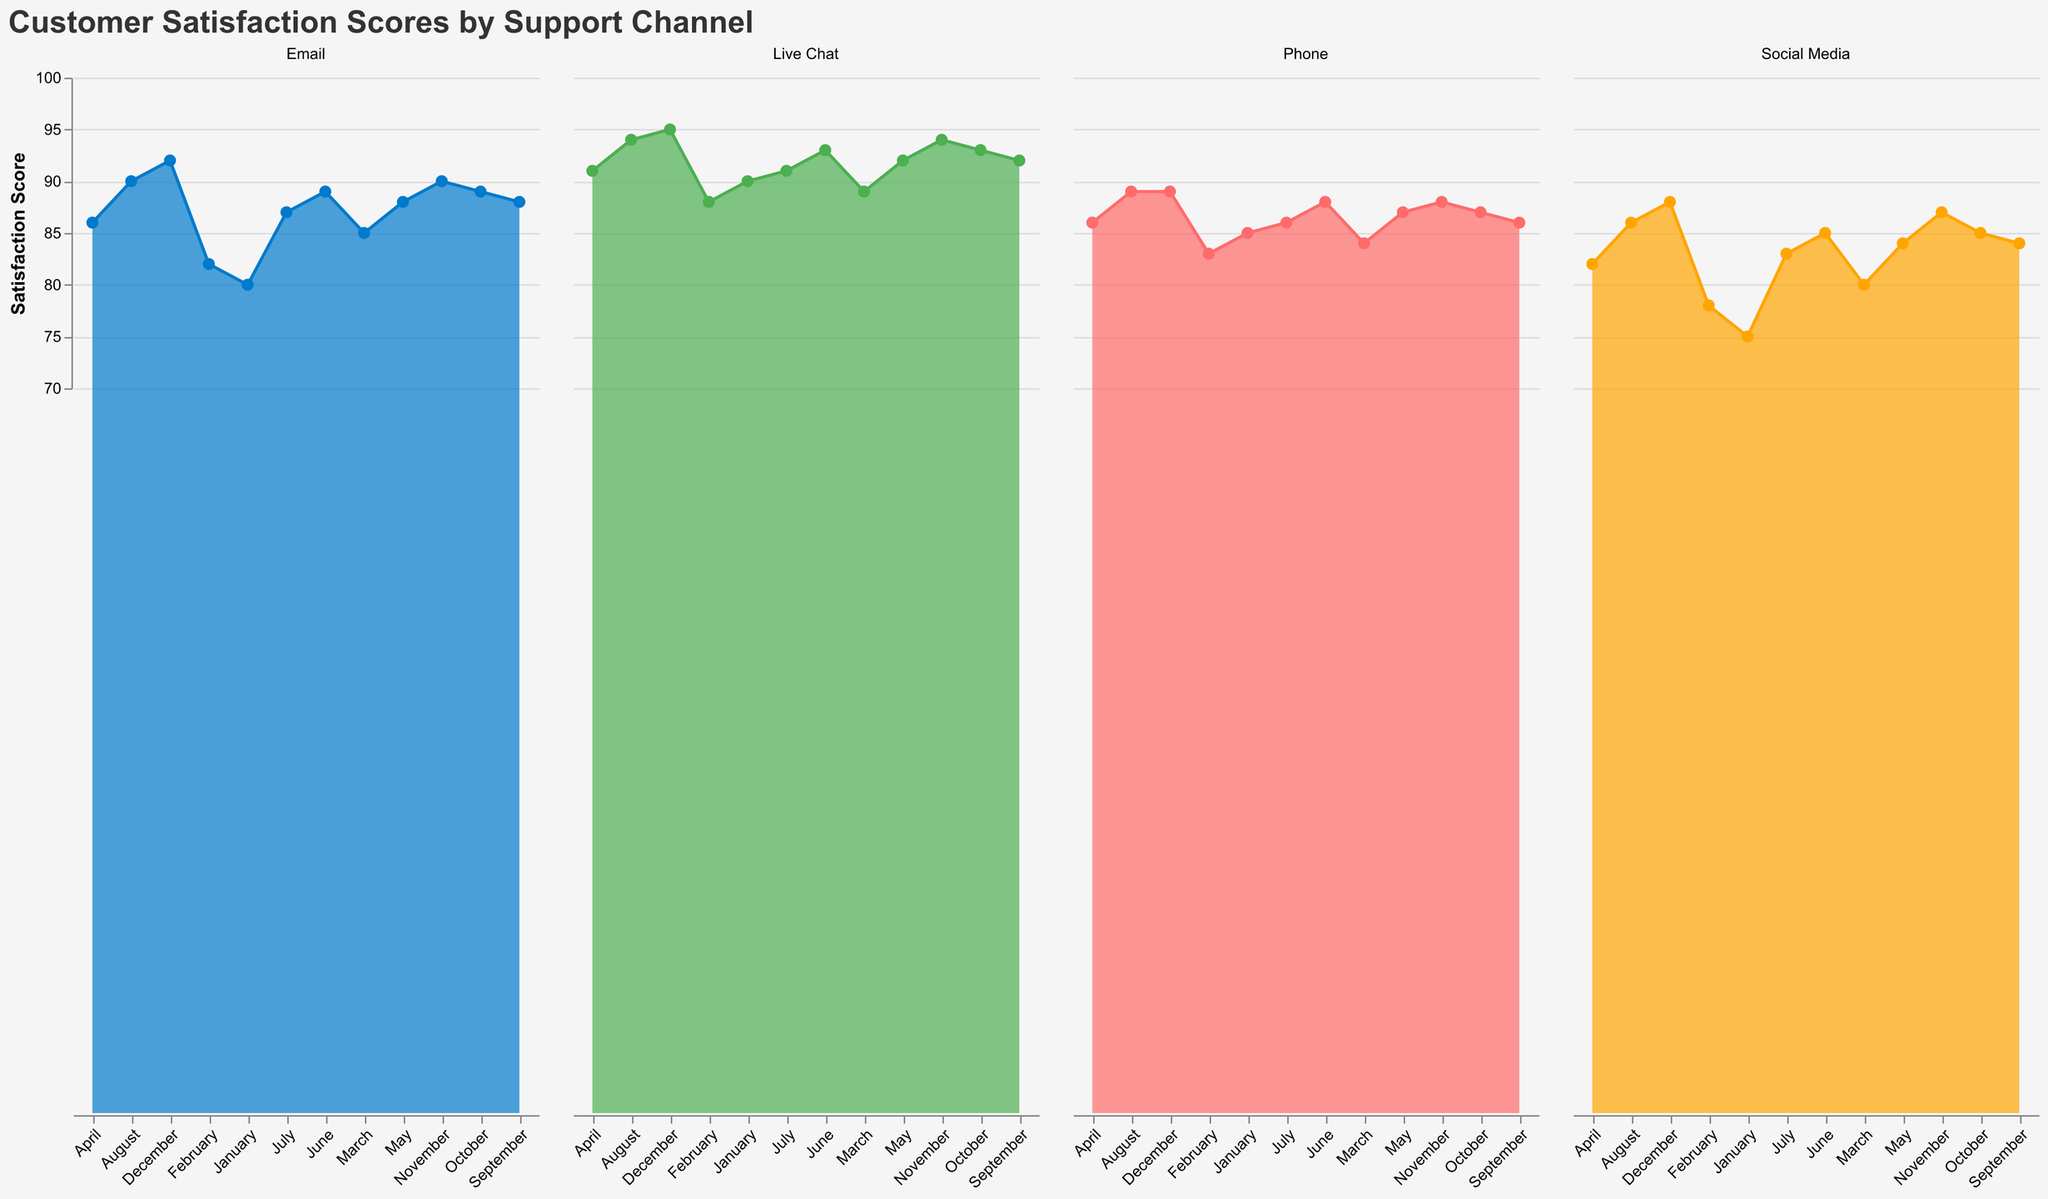What's the title of the figure? The title is written at the top of the figure and provides an overview of what the figure is about. It reads "Customer Satisfaction Scores by Support Channel".
Answer: "Customer Satisfaction Scores by Support Channel" What are the four support channels shown in the figure? The support channels are labeled in the legend, which uses different colors to distinguish them. The channels are Email, Phone, Live Chat, and Social Media.
Answer: Email, Phone, Live Chat, Social Media In which month did Email have the highest satisfaction score? Observing the Email channel across the months, the highest score for Email is in December, with a score of 92.
Answer: December What is the lowest satisfaction score recorded for Social Media, and in which month? By looking at the Social Media subplot, the lowest score is 75, recorded in January.
Answer: 75, January How does the satisfaction score for Live Chat in April compare to that in October? Checking the Live Chat subplot, both April and October have the same satisfaction score of 91.
Answer: They are equal, 91 Which channel has the most consistent satisfaction scores throughout the year? Consistency can be judged by the variation in scores. By comparing the subplots, Phone has the most consistent scores, varying only from 83 to 89.
Answer: Phone What's the average satisfaction score for the Live Chat channel for the entire year? To find the average, sum up the monthly scores for Live Chat: 90+88+89+91+92+93+91+94+92+93+94+95 = 1102. Then divide by 12 (number of months): 1102 / 12 = 91.83.
Answer: 91.83 Which month has the highest overall satisfaction score across all channels? To determine the highest overall, all channel scores for each month need to be summed and compared. December has the highest cumulative score: 92 (Email) + 89 (Phone) + 95 (Live Chat) + 88 (Social Media) = 364.
Answer: December Is there any month where all support channels' satisfaction scores increased compared to the previous month? If so, which month? Each channel's scores for months need to be compared sequentially. From July to August, all channels (Email, Phone, Live Chat, Social Media) show an increase.
Answer: August 